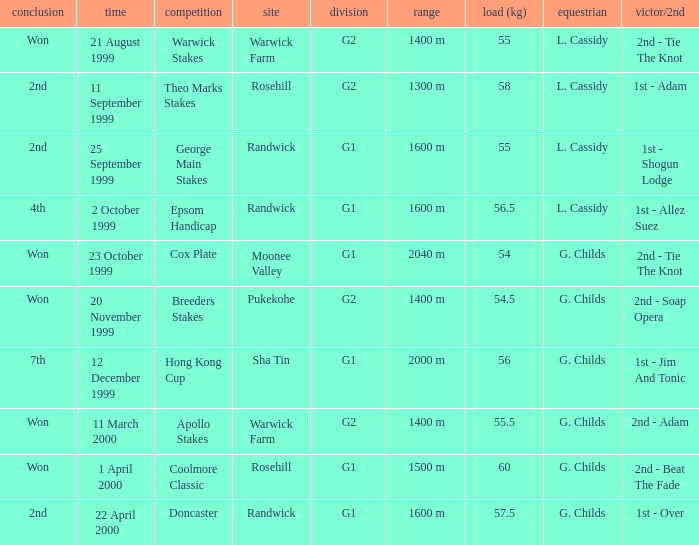5 kilograms. Epsom Handicap. 